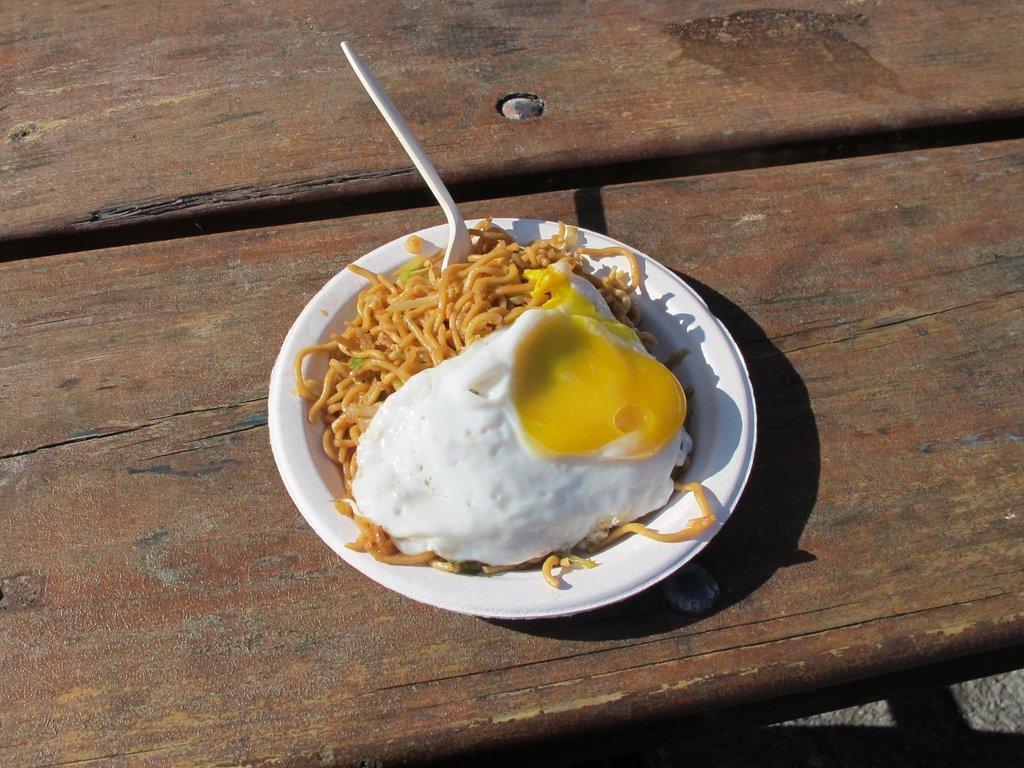How would you summarize this image in a sentence or two? In this image I can see noodles and egg omelette in a plate kept on the table. This image is taken during a day. 